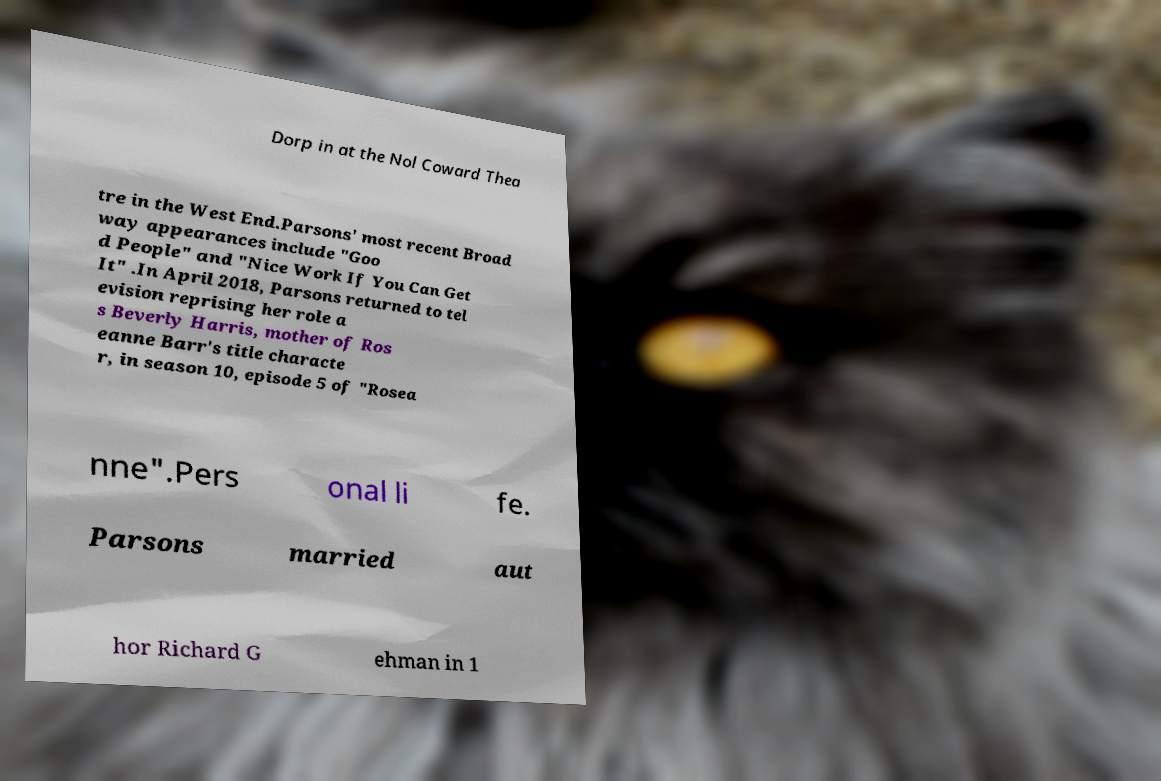What messages or text are displayed in this image? I need them in a readable, typed format. Dorp in at the Nol Coward Thea tre in the West End.Parsons' most recent Broad way appearances include "Goo d People" and "Nice Work If You Can Get It" .In April 2018, Parsons returned to tel evision reprising her role a s Beverly Harris, mother of Ros eanne Barr's title characte r, in season 10, episode 5 of "Rosea nne".Pers onal li fe. Parsons married aut hor Richard G ehman in 1 